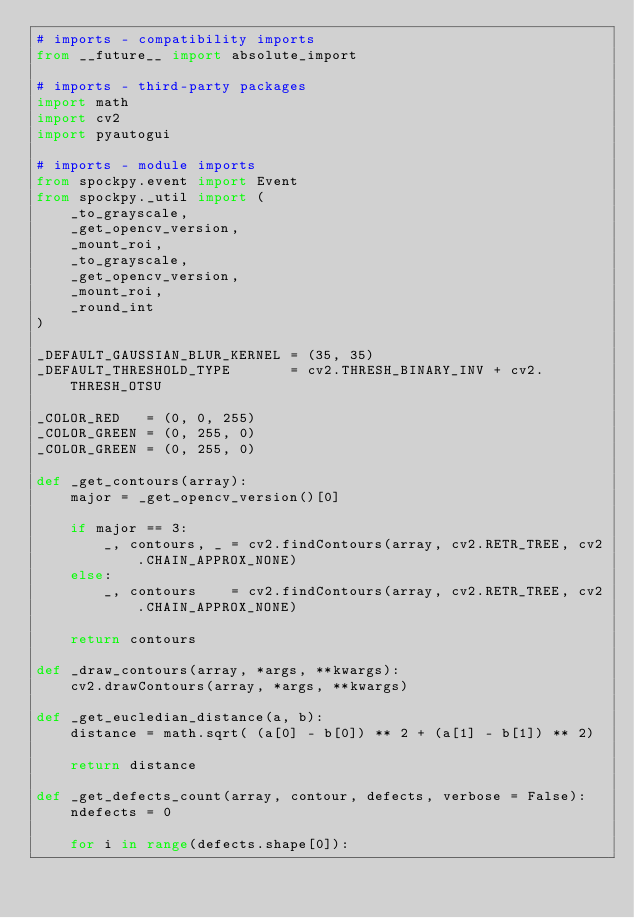Convert code to text. <code><loc_0><loc_0><loc_500><loc_500><_Python_># imports - compatibility imports
from __future__ import absolute_import

# imports - third-party packages
import math
import cv2
import pyautogui

# imports - module imports
from spockpy.event import Event
from spockpy._util import (
    _to_grayscale,
    _get_opencv_version,
    _mount_roi,
    _to_grayscale,
    _get_opencv_version,
    _mount_roi,
    _round_int
)

_DEFAULT_GAUSSIAN_BLUR_KERNEL = (35, 35)
_DEFAULT_THRESHOLD_TYPE       = cv2.THRESH_BINARY_INV + cv2.THRESH_OTSU

_COLOR_RED   = (0, 0, 255)
_COLOR_GREEN = (0, 255, 0)
_COLOR_GREEN = (0, 255, 0)

def _get_contours(array):
    major = _get_opencv_version()[0]

    if major == 3:
        _, contours, _ = cv2.findContours(array, cv2.RETR_TREE, cv2.CHAIN_APPROX_NONE)
    else:
        _, contours    = cv2.findContours(array, cv2.RETR_TREE, cv2.CHAIN_APPROX_NONE)

    return contours

def _draw_contours(array, *args, **kwargs):
    cv2.drawContours(array, *args, **kwargs)

def _get_eucledian_distance(a, b):
    distance = math.sqrt( (a[0] - b[0]) ** 2 + (a[1] - b[1]) ** 2)

    return distance

def _get_defects_count(array, contour, defects, verbose = False):
    ndefects = 0
    
    for i in range(defects.shape[0]):</code> 